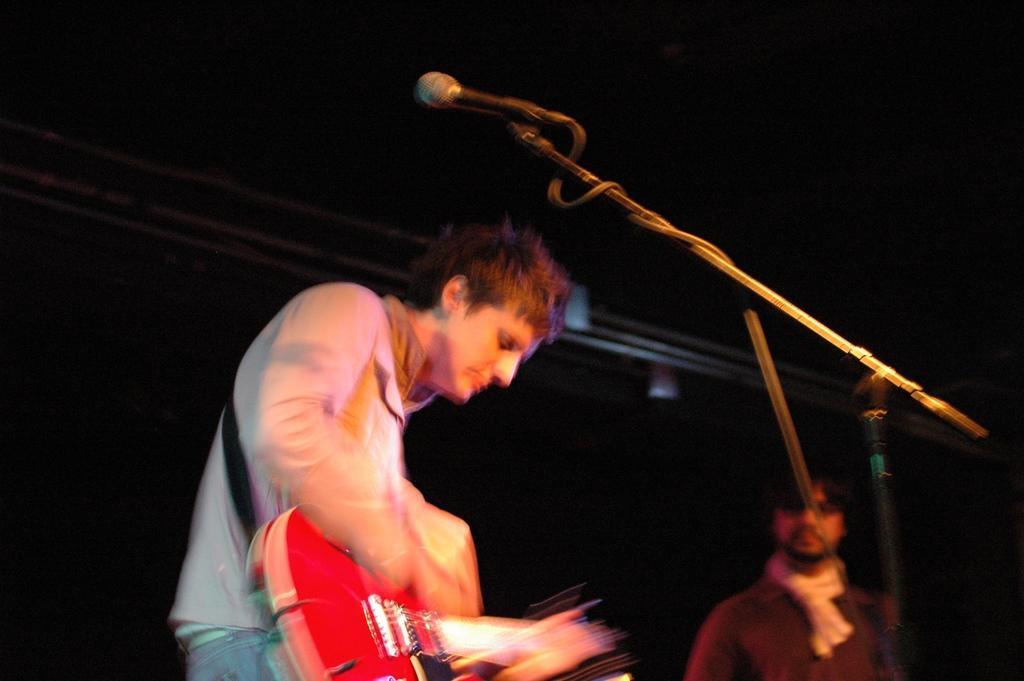Can you describe this image briefly? In this 2 people a person is playing guitar here on the left and there is a mic over here. 